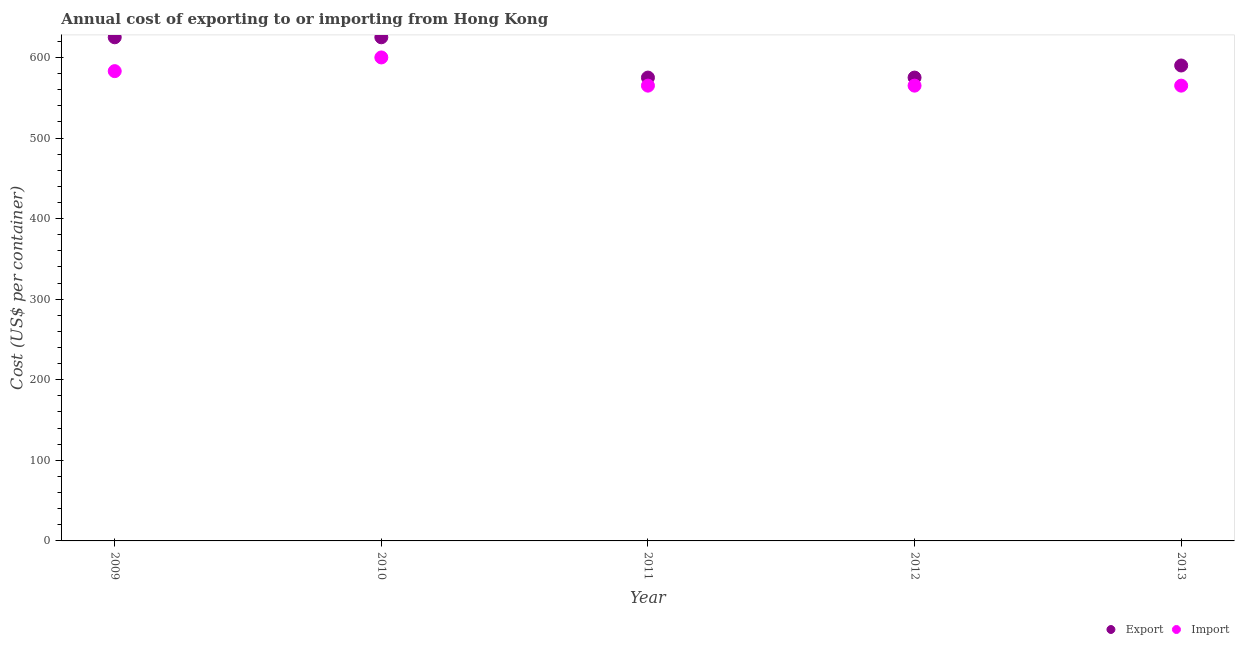How many different coloured dotlines are there?
Offer a very short reply. 2. Is the number of dotlines equal to the number of legend labels?
Your answer should be very brief. Yes. What is the export cost in 2009?
Your answer should be compact. 625. Across all years, what is the maximum export cost?
Your response must be concise. 625. Across all years, what is the minimum import cost?
Keep it short and to the point. 565. What is the total export cost in the graph?
Your answer should be compact. 2990. What is the difference between the export cost in 2010 and that in 2011?
Offer a terse response. 50. What is the difference between the export cost in 2010 and the import cost in 2009?
Your response must be concise. 42. What is the average export cost per year?
Your answer should be very brief. 598. In the year 2012, what is the difference between the export cost and import cost?
Your answer should be very brief. 10. What is the ratio of the import cost in 2009 to that in 2011?
Ensure brevity in your answer.  1.03. Is the import cost in 2010 less than that in 2012?
Keep it short and to the point. No. What is the difference between the highest and the second highest export cost?
Give a very brief answer. 0. What is the difference between the highest and the lowest export cost?
Provide a short and direct response. 50. Does the import cost monotonically increase over the years?
Your response must be concise. No. Is the import cost strictly greater than the export cost over the years?
Offer a very short reply. No. How many dotlines are there?
Make the answer very short. 2. How many years are there in the graph?
Make the answer very short. 5. What is the difference between two consecutive major ticks on the Y-axis?
Ensure brevity in your answer.  100. Does the graph contain any zero values?
Provide a short and direct response. No. Does the graph contain grids?
Offer a terse response. No. How are the legend labels stacked?
Ensure brevity in your answer.  Horizontal. What is the title of the graph?
Your answer should be compact. Annual cost of exporting to or importing from Hong Kong. Does "Primary education" appear as one of the legend labels in the graph?
Provide a succinct answer. No. What is the label or title of the Y-axis?
Keep it short and to the point. Cost (US$ per container). What is the Cost (US$ per container) in Export in 2009?
Make the answer very short. 625. What is the Cost (US$ per container) in Import in 2009?
Your answer should be compact. 583. What is the Cost (US$ per container) in Export in 2010?
Make the answer very short. 625. What is the Cost (US$ per container) in Import in 2010?
Make the answer very short. 600. What is the Cost (US$ per container) in Export in 2011?
Make the answer very short. 575. What is the Cost (US$ per container) of Import in 2011?
Your response must be concise. 565. What is the Cost (US$ per container) of Export in 2012?
Keep it short and to the point. 575. What is the Cost (US$ per container) in Import in 2012?
Make the answer very short. 565. What is the Cost (US$ per container) of Export in 2013?
Offer a terse response. 590. What is the Cost (US$ per container) in Import in 2013?
Give a very brief answer. 565. Across all years, what is the maximum Cost (US$ per container) of Export?
Give a very brief answer. 625. Across all years, what is the maximum Cost (US$ per container) of Import?
Your answer should be compact. 600. Across all years, what is the minimum Cost (US$ per container) in Export?
Provide a succinct answer. 575. Across all years, what is the minimum Cost (US$ per container) of Import?
Ensure brevity in your answer.  565. What is the total Cost (US$ per container) in Export in the graph?
Make the answer very short. 2990. What is the total Cost (US$ per container) of Import in the graph?
Your answer should be compact. 2878. What is the difference between the Cost (US$ per container) in Export in 2009 and that in 2011?
Give a very brief answer. 50. What is the difference between the Cost (US$ per container) of Import in 2009 and that in 2011?
Keep it short and to the point. 18. What is the difference between the Cost (US$ per container) of Export in 2009 and that in 2012?
Your answer should be compact. 50. What is the difference between the Cost (US$ per container) in Import in 2009 and that in 2012?
Offer a very short reply. 18. What is the difference between the Cost (US$ per container) of Import in 2010 and that in 2011?
Your answer should be compact. 35. What is the difference between the Cost (US$ per container) of Export in 2010 and that in 2013?
Provide a short and direct response. 35. What is the difference between the Cost (US$ per container) of Import in 2010 and that in 2013?
Provide a short and direct response. 35. What is the difference between the Cost (US$ per container) of Import in 2011 and that in 2012?
Make the answer very short. 0. What is the difference between the Cost (US$ per container) of Import in 2012 and that in 2013?
Your answer should be compact. 0. What is the difference between the Cost (US$ per container) in Export in 2009 and the Cost (US$ per container) in Import in 2010?
Offer a terse response. 25. What is the difference between the Cost (US$ per container) of Export in 2009 and the Cost (US$ per container) of Import in 2011?
Offer a terse response. 60. What is the difference between the Cost (US$ per container) of Export in 2009 and the Cost (US$ per container) of Import in 2012?
Provide a short and direct response. 60. What is the difference between the Cost (US$ per container) of Export in 2011 and the Cost (US$ per container) of Import in 2012?
Make the answer very short. 10. What is the difference between the Cost (US$ per container) in Export in 2011 and the Cost (US$ per container) in Import in 2013?
Offer a terse response. 10. What is the difference between the Cost (US$ per container) of Export in 2012 and the Cost (US$ per container) of Import in 2013?
Provide a short and direct response. 10. What is the average Cost (US$ per container) in Export per year?
Offer a terse response. 598. What is the average Cost (US$ per container) in Import per year?
Give a very brief answer. 575.6. In the year 2010, what is the difference between the Cost (US$ per container) of Export and Cost (US$ per container) of Import?
Offer a terse response. 25. In the year 2011, what is the difference between the Cost (US$ per container) of Export and Cost (US$ per container) of Import?
Give a very brief answer. 10. In the year 2012, what is the difference between the Cost (US$ per container) in Export and Cost (US$ per container) in Import?
Make the answer very short. 10. What is the ratio of the Cost (US$ per container) in Import in 2009 to that in 2010?
Provide a short and direct response. 0.97. What is the ratio of the Cost (US$ per container) of Export in 2009 to that in 2011?
Keep it short and to the point. 1.09. What is the ratio of the Cost (US$ per container) in Import in 2009 to that in 2011?
Offer a very short reply. 1.03. What is the ratio of the Cost (US$ per container) in Export in 2009 to that in 2012?
Your response must be concise. 1.09. What is the ratio of the Cost (US$ per container) in Import in 2009 to that in 2012?
Provide a succinct answer. 1.03. What is the ratio of the Cost (US$ per container) in Export in 2009 to that in 2013?
Make the answer very short. 1.06. What is the ratio of the Cost (US$ per container) of Import in 2009 to that in 2013?
Give a very brief answer. 1.03. What is the ratio of the Cost (US$ per container) in Export in 2010 to that in 2011?
Offer a terse response. 1.09. What is the ratio of the Cost (US$ per container) in Import in 2010 to that in 2011?
Keep it short and to the point. 1.06. What is the ratio of the Cost (US$ per container) of Export in 2010 to that in 2012?
Make the answer very short. 1.09. What is the ratio of the Cost (US$ per container) in Import in 2010 to that in 2012?
Your response must be concise. 1.06. What is the ratio of the Cost (US$ per container) in Export in 2010 to that in 2013?
Ensure brevity in your answer.  1.06. What is the ratio of the Cost (US$ per container) of Import in 2010 to that in 2013?
Your answer should be compact. 1.06. What is the ratio of the Cost (US$ per container) of Export in 2011 to that in 2013?
Keep it short and to the point. 0.97. What is the ratio of the Cost (US$ per container) of Export in 2012 to that in 2013?
Give a very brief answer. 0.97. What is the difference between the highest and the second highest Cost (US$ per container) in Import?
Your answer should be compact. 17. What is the difference between the highest and the lowest Cost (US$ per container) in Import?
Provide a succinct answer. 35. 